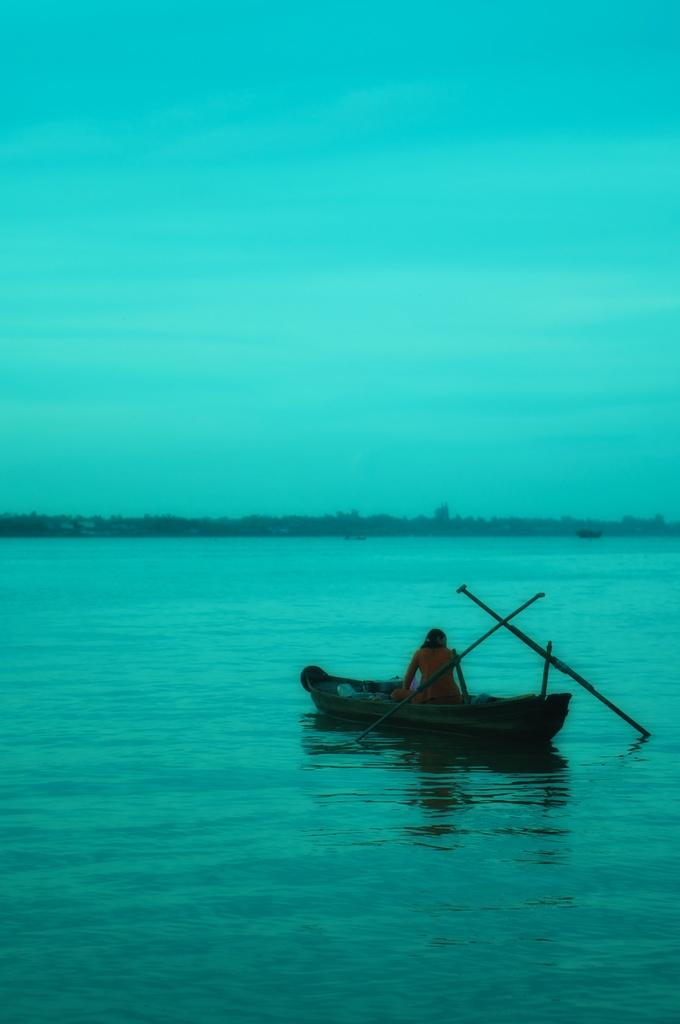What is the main subject of the image? The main subject of the image is a boat. Where is the boat located? The boat is on the water. Is there anyone in the boat? Yes, there is a person sitting in the boat. What is the color of the water in the image? The water is green in color. What is the color of the sky in the image? The sky is blue in color. What type of marble is being used as a texture on the boat in the image? There is no marble present in the image, and the boat does not have any texture made of marble. 